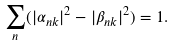<formula> <loc_0><loc_0><loc_500><loc_500>\sum _ { n } ( | \alpha _ { n k } | ^ { 2 } - | \beta _ { n k } | ^ { 2 } ) = 1 .</formula> 